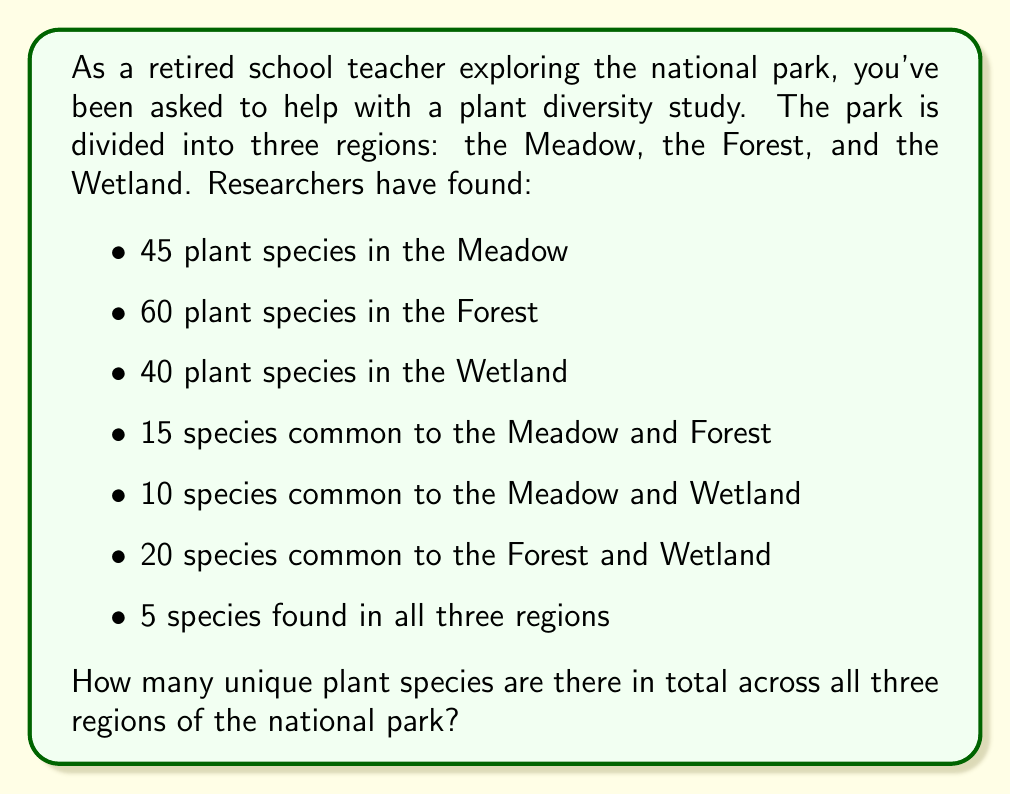Show me your answer to this math problem. To solve this problem, we'll use the principle of inclusion-exclusion for three sets. Let's define our sets:

$M$ = plant species in the Meadow
$F$ = plant species in the Forest
$W$ = plant species in the Wetland

We're given:
$|M| = 45$, $|F| = 60$, $|W| = 40$
$|M \cap F| = 15$, $|M \cap W| = 10$, $|F \cap W| = 20$
$|M \cap F \cap W| = 5$

The formula for the total number of unique elements in three sets is:

$$ |M \cup F \cup W| = |M| + |F| + |W| - |M \cap F| - |M \cap W| - |F \cap W| + |M \cap F \cap W| $$

Now, let's substitute our values:

$$ |M \cup F \cup W| = 45 + 60 + 40 - 15 - 10 - 20 + 5 $$

Simplifying:
$$ |M \cup F \cup W| = 145 - 45 + 5 = 105 $$

Therefore, there are 105 unique plant species across all three regions of the national park.
Answer: 105 unique plant species 